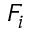Convert formula to latex. <formula><loc_0><loc_0><loc_500><loc_500>F _ { i }</formula> 